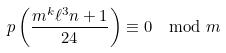<formula> <loc_0><loc_0><loc_500><loc_500>p \left ( \frac { m ^ { k } \ell ^ { 3 } n + 1 } { 2 4 } \right ) \equiv 0 \mod m</formula> 